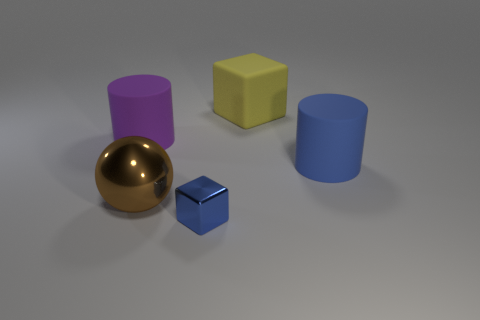Add 3 purple rubber cylinders. How many objects exist? 8 Subtract all cylinders. How many objects are left? 3 Add 5 big matte objects. How many big matte objects are left? 8 Add 5 large purple rubber cylinders. How many large purple rubber cylinders exist? 6 Subtract 0 brown cylinders. How many objects are left? 5 Subtract all big blue cylinders. Subtract all purple matte cylinders. How many objects are left? 3 